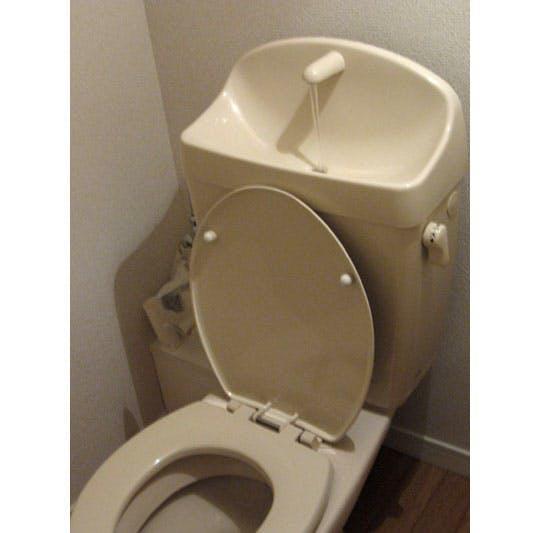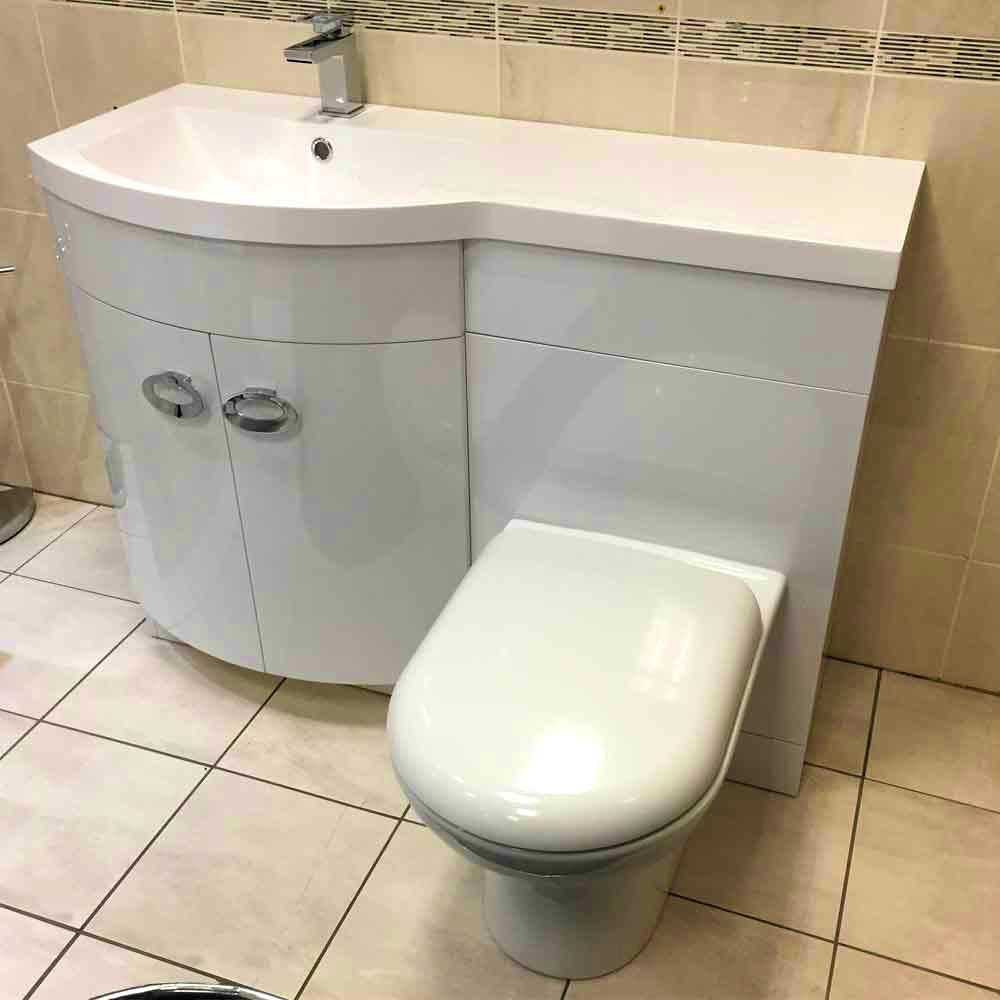The first image is the image on the left, the second image is the image on the right. Assess this claim about the two images: "At least one toilet is visible in every picture and all toilets have their lids closed.". Correct or not? Answer yes or no. No. 